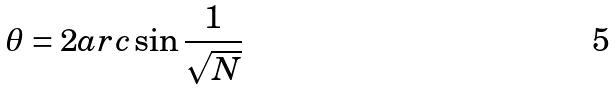<formula> <loc_0><loc_0><loc_500><loc_500>\theta = 2 a r c \sin \frac { 1 } { \sqrt { N } }</formula> 